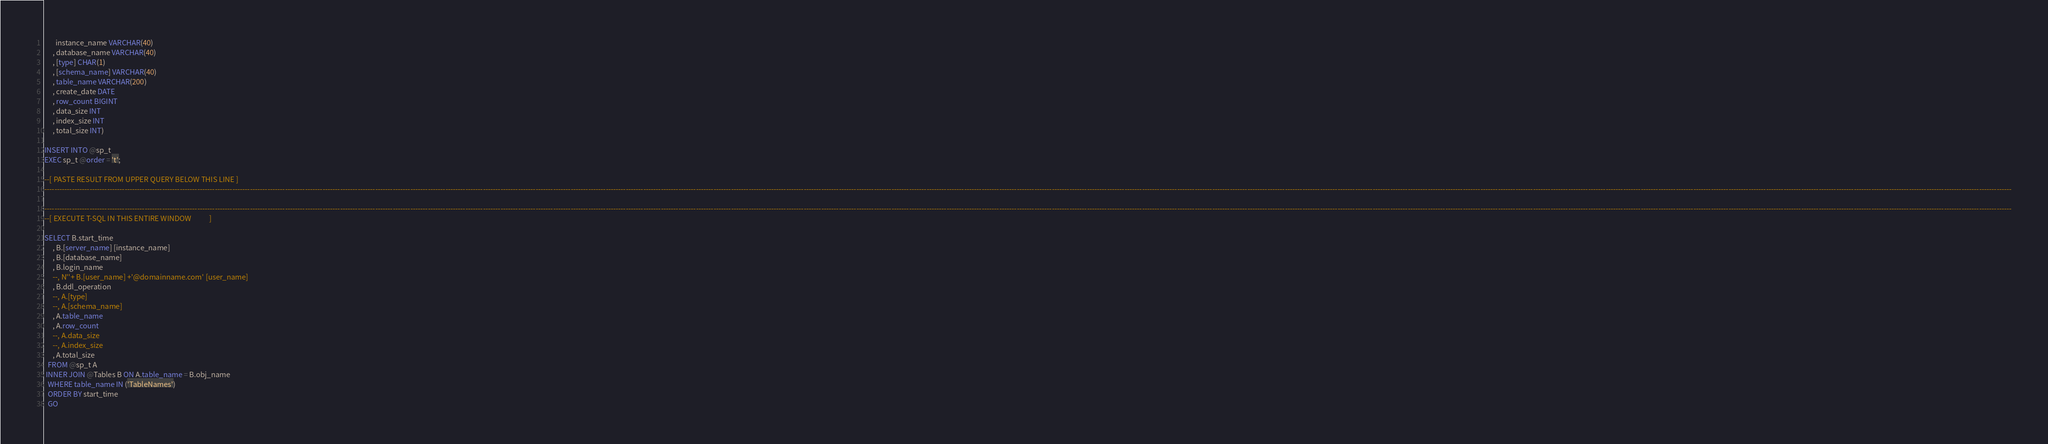<code> <loc_0><loc_0><loc_500><loc_500><_SQL_>       instance_name VARCHAR(40)
     , database_name VARCHAR(40)
     , [type] CHAR(1)
     , [schema_name] VARCHAR(40)
     , table_name VARCHAR(200)
     , create_date DATE
     , row_count BIGINT
     , data_size INT
     , index_size INT
     , total_size INT)

INSERT INTO @sp_t
EXEC sp_t @order = 't';

--[ PASTE RESULT FROM UPPER QUERY BELOW THIS LINE ]
-----------------------------------------------------------------------------------------------------------------------------------------------------------------------------------------------------------------------------------------------------------------------------------------------------------------------------------------------------------------------------------------------------------------------------------------------------------------------------------------------------------------------------------------------------------------------------------------------------------------------------------------------------------------------------------------------------------------------------------------------------------------------------------------------------------------

-----------------------------------------------------------------------------------------------------------------------------------------------------------------------------------------------------------------------------------------------------------------------------------------------------------------------------------------------------------------------------------------------------------------------------------------------------------------------------------------------------------------------------------------------------------------------------------------------------------------------------------------------------------------------------------------------------------------------------------------------------------------------------------------------------------------
--[ EXECUTE T-SQL IN THIS ENTIRE WINDOW           ]

SELECT B.start_time
     , B.[server_name] [instance_name]
     , B.[database_name]
     , B.login_name
     --, N''+ B.[user_name] +'@domainname.com' [user_name]
     , B.ddl_operation
     --, A.[type]
     --, A.[schema_name]
     , A.table_name
     , A.row_count
     --, A.data_size
     --, A.index_size
     , A.total_size
  FROM @sp_t A
 INNER JOIN @Tables B ON A.table_name = B.obj_name
  WHERE table_name IN ('TableNames')
  ORDER BY start_time
  GO
</code> 